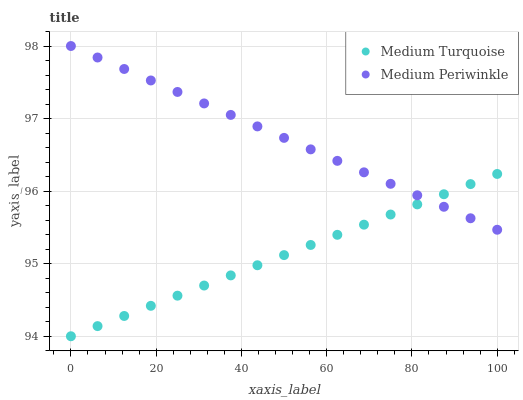Does Medium Turquoise have the minimum area under the curve?
Answer yes or no. Yes. Does Medium Periwinkle have the maximum area under the curve?
Answer yes or no. Yes. Does Medium Turquoise have the maximum area under the curve?
Answer yes or no. No. Is Medium Periwinkle the smoothest?
Answer yes or no. Yes. Is Medium Turquoise the roughest?
Answer yes or no. Yes. Is Medium Turquoise the smoothest?
Answer yes or no. No. Does Medium Turquoise have the lowest value?
Answer yes or no. Yes. Does Medium Periwinkle have the highest value?
Answer yes or no. Yes. Does Medium Turquoise have the highest value?
Answer yes or no. No. Does Medium Periwinkle intersect Medium Turquoise?
Answer yes or no. Yes. Is Medium Periwinkle less than Medium Turquoise?
Answer yes or no. No. Is Medium Periwinkle greater than Medium Turquoise?
Answer yes or no. No. 